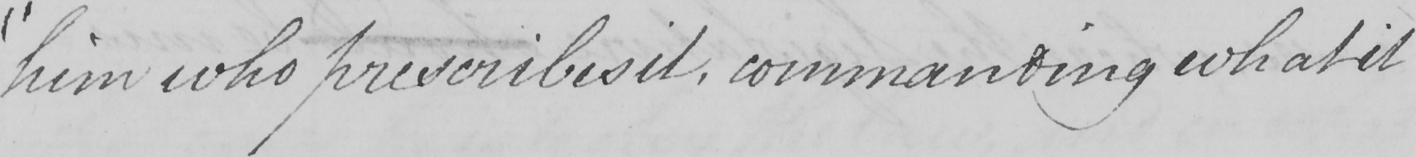Can you tell me what this handwritten text says? " him who prescribes it , commanding what it 